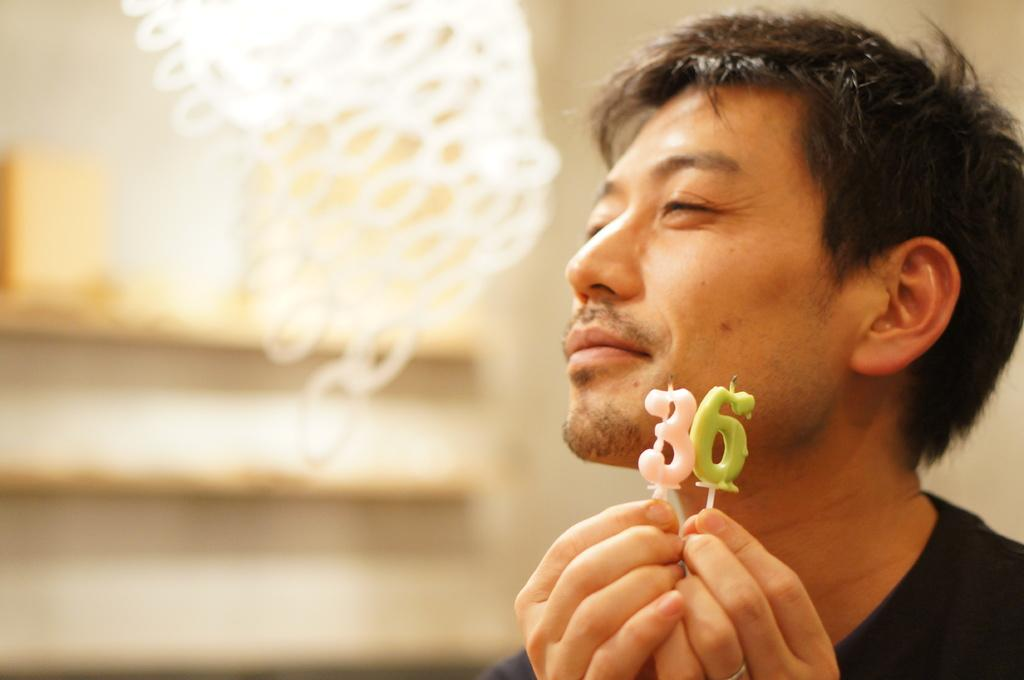What is the main subject in the foreground of the image? There is a person in the foreground of the image. What is the person holding in the image? The person is holding candles. What can be seen in the background of the image? There is a wall in the background of the image. What type of riddle is the person trying to solve in the image? There is no riddle present in the image; the person is simply holding candles. Can you tell me how many times the person jumps in the image? There is no jumping activity depicted in the image; the person is holding candles and standing still. 